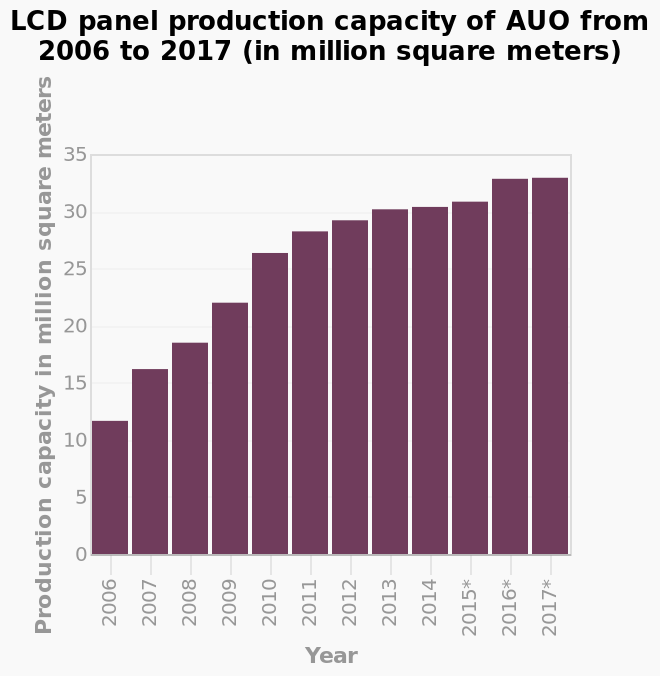<image>
During which years were the LCD panel production capacities of AUO particularly close?  The LCD panel production capacities of AUO were particularly close in the years 2016 and 2017. What is the scale used on the x-axis? The x-axis uses a categorical scale, representing the years from 2006 to 2017. What is the unit of measurement for the y-axis? The y-axis represents the production capacity in million square meters. 